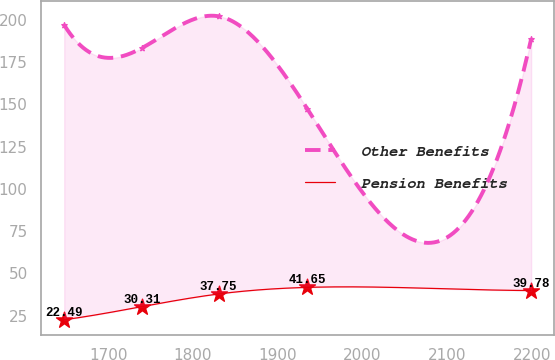<chart> <loc_0><loc_0><loc_500><loc_500><line_chart><ecel><fcel>Other Benefits<fcel>Pension Benefits<nl><fcel>1648.29<fcel>197<fcel>22.49<nl><fcel>1740.44<fcel>183.55<fcel>30.31<nl><fcel>1830.32<fcel>202.18<fcel>37.75<nl><fcel>1934.79<fcel>147.41<fcel>41.65<nl><fcel>2198.6<fcel>188.73<fcel>39.78<nl></chart> 